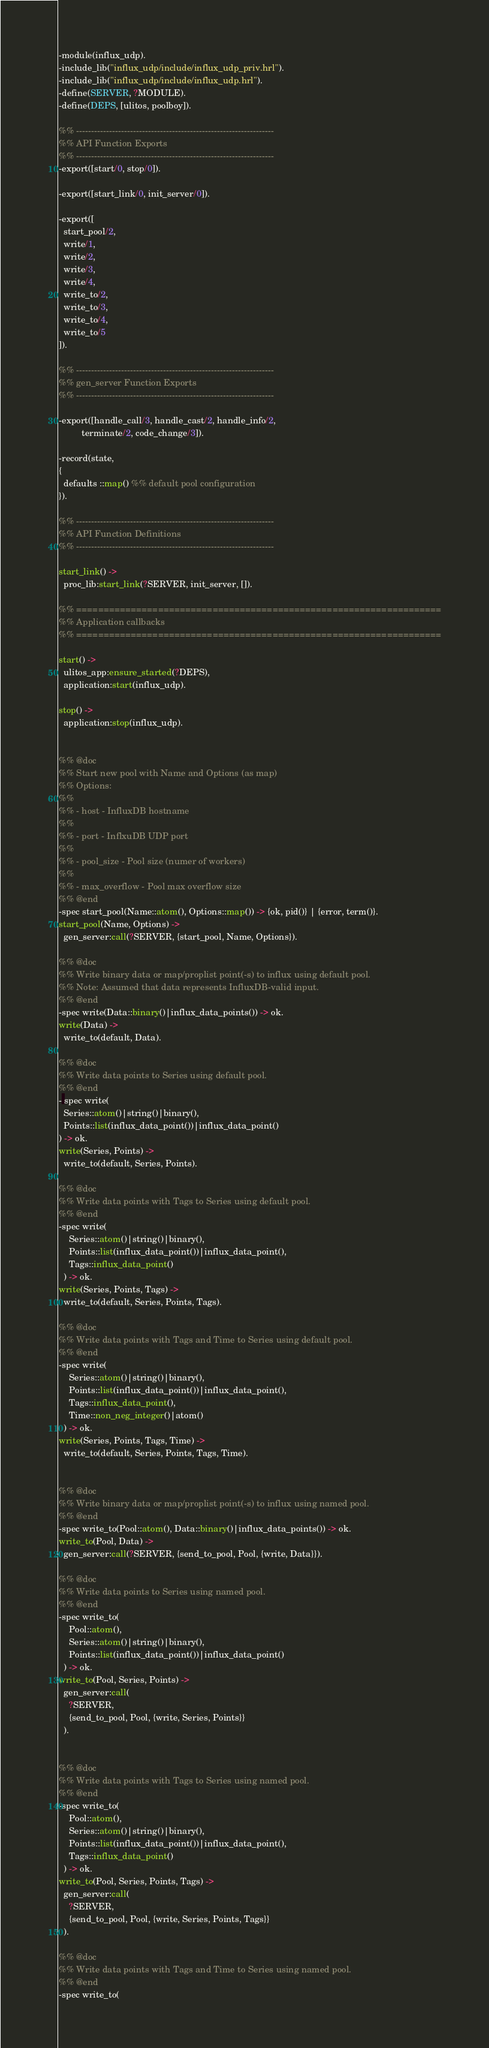Convert code to text. <code><loc_0><loc_0><loc_500><loc_500><_Erlang_>-module(influx_udp).
-include_lib("influx_udp/include/influx_udp_priv.hrl").
-include_lib("influx_udp/include/influx_udp.hrl").
-define(SERVER, ?MODULE).
-define(DEPS, [ulitos, poolboy]).

%% ------------------------------------------------------------------
%% API Function Exports
%% ------------------------------------------------------------------
-export([start/0, stop/0]).

-export([start_link/0, init_server/0]).

-export([
  start_pool/2,
  write/1,
  write/2,
  write/3,
  write/4,
  write_to/2,
  write_to/3,
  write_to/4,
  write_to/5
]).

%% ------------------------------------------------------------------
%% gen_server Function Exports
%% ------------------------------------------------------------------

-export([handle_call/3, handle_cast/2, handle_info/2,
         terminate/2, code_change/3]).

-record(state,
{
  defaults ::map() %% default pool configuration
}).

%% ------------------------------------------------------------------
%% API Function Definitions
%% ------------------------------------------------------------------

start_link() ->
  proc_lib:start_link(?SERVER, init_server, []).

%% ===================================================================
%% Application callbacks
%% ===================================================================

start() ->
  ulitos_app:ensure_started(?DEPS),
  application:start(influx_udp).

stop() ->
  application:stop(influx_udp).


%% @doc
%% Start new pool with Name and Options (as map)
%% Options:
%%
%% - host - InfluxDB hostname
%%
%% - port - InflxuDB UDP port
%%
%% - pool_size - Pool size (numer of workers)
%%
%% - max_overflow - Pool max overflow size
%% @end
-spec start_pool(Name::atom(), Options::map()) -> {ok, pid()} | {error, term()}.
start_pool(Name, Options) ->
  gen_server:call(?SERVER, {start_pool, Name, Options}).

%% @doc
%% Write binary data or map/proplist point(-s) to influx using default pool.
%% Note: Assumed that data represents InfluxDB-valid input.
%% @end
-spec write(Data::binary()|influx_data_points()) -> ok.
write(Data) ->
  write_to(default, Data).

%% @doc
%% Write data points to Series using default pool.
%% @end
- spec write(
  Series::atom()|string()|binary(),
  Points::list(influx_data_point())|influx_data_point()
) -> ok.
write(Series, Points) ->
  write_to(default, Series, Points).

%% @doc
%% Write data points with Tags to Series using default pool.
%% @end
-spec write(
    Series::atom()|string()|binary(),
    Points::list(influx_data_point())|influx_data_point(),
    Tags::influx_data_point()
  ) -> ok.
write(Series, Points, Tags) ->
  write_to(default, Series, Points, Tags).

%% @doc
%% Write data points with Tags and Time to Series using default pool.
%% @end
-spec write(
    Series::atom()|string()|binary(),
    Points::list(influx_data_point())|influx_data_point(),
    Tags::influx_data_point(),
    Time::non_neg_integer()|atom()
  ) -> ok.
write(Series, Points, Tags, Time) ->
  write_to(default, Series, Points, Tags, Time).


%% @doc
%% Write binary data or map/proplist point(-s) to influx using named pool.
%% @end
-spec write_to(Pool::atom(), Data::binary()|influx_data_points()) -> ok.
write_to(Pool, Data) ->
  gen_server:call(?SERVER, {send_to_pool, Pool, {write, Data}}).

%% @doc
%% Write data points to Series using named pool.
%% @end
-spec write_to(
    Pool::atom(),
    Series::atom()|string()|binary(),
    Points::list(influx_data_point())|influx_data_point()
  ) -> ok.
write_to(Pool, Series, Points) ->
  gen_server:call(
    ?SERVER,
    {send_to_pool, Pool, {write, Series, Points}}
  ).


%% @doc
%% Write data points with Tags to Series using named pool.
%% @end
-spec write_to(
    Pool::atom(),
    Series::atom()|string()|binary(),
    Points::list(influx_data_point())|influx_data_point(),
    Tags::influx_data_point()
  ) -> ok.
write_to(Pool, Series, Points, Tags) ->
  gen_server:call(
    ?SERVER,
    {send_to_pool, Pool, {write, Series, Points, Tags}}
  ).

%% @doc
%% Write data points with Tags and Time to Series using named pool.
%% @end
-spec write_to(</code> 